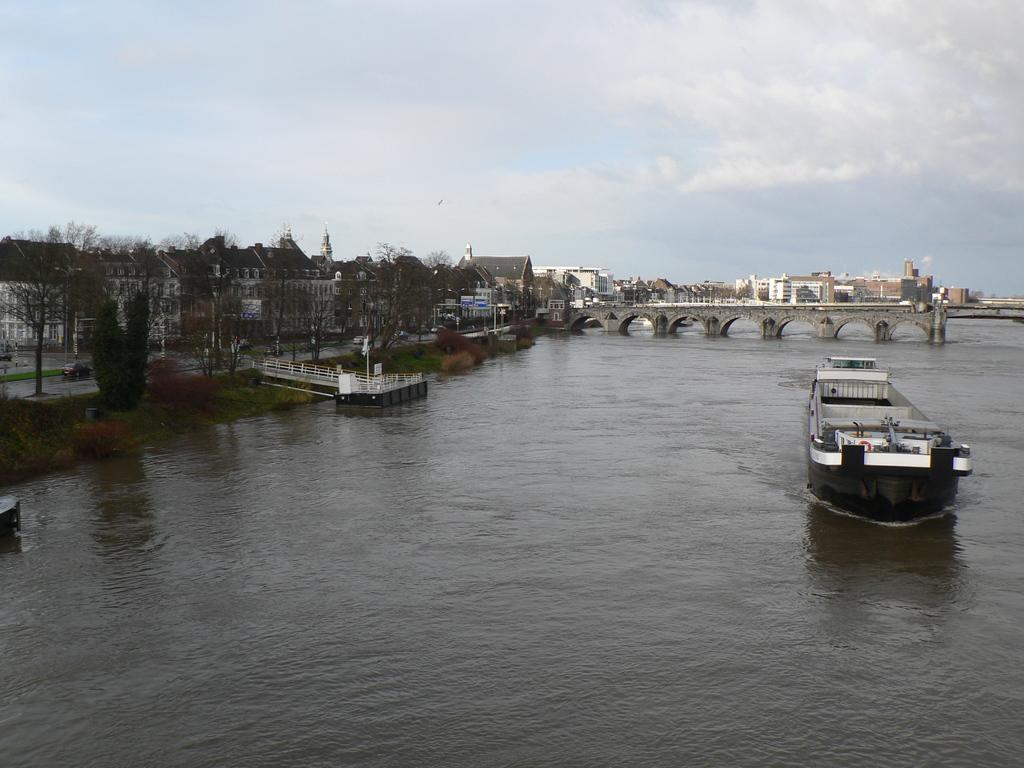How would you summarize this image in a sentence or two? At the bottom, we see water and this water might be in the river. On the right side, we see a boat sailing on the water. In the middle, we see an arch bridge. On the left side, we see a pole and the railing. Beside that, we see the trees, street lights, poles and the buildings. There are buildings in the background. At the top, we see the sky and the clouds. 